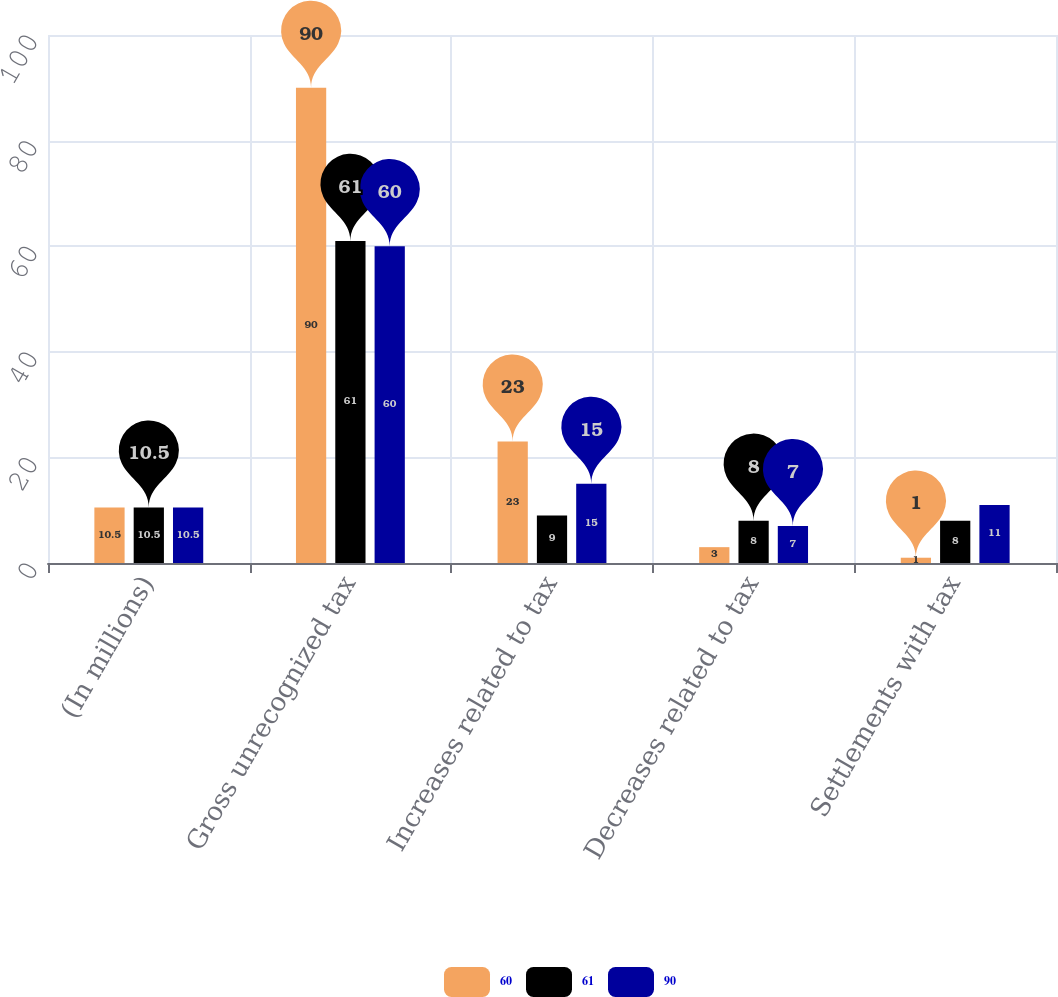Convert chart. <chart><loc_0><loc_0><loc_500><loc_500><stacked_bar_chart><ecel><fcel>(In millions)<fcel>Gross unrecognized tax<fcel>Increases related to tax<fcel>Decreases related to tax<fcel>Settlements with tax<nl><fcel>60<fcel>10.5<fcel>90<fcel>23<fcel>3<fcel>1<nl><fcel>61<fcel>10.5<fcel>61<fcel>9<fcel>8<fcel>8<nl><fcel>90<fcel>10.5<fcel>60<fcel>15<fcel>7<fcel>11<nl></chart> 